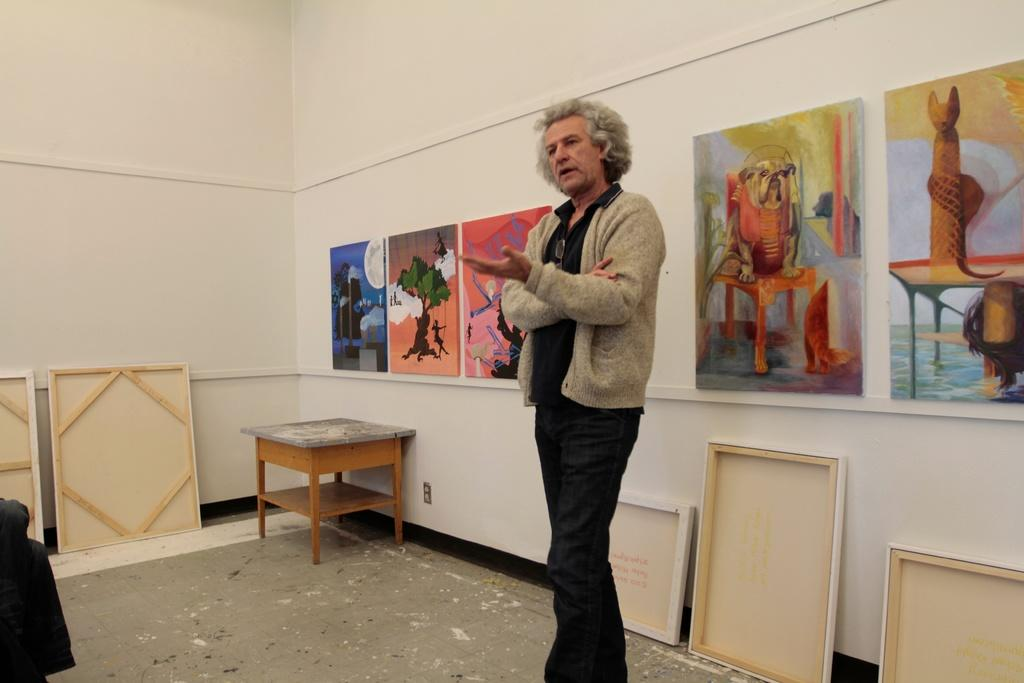What is the main subject of the picture? There is a person standing in the picture. Where is the person located? The person is in a room. What furniture can be seen in the room? There is a table in the room. What decorative elements are present in the background? There are photographs attached to the wall in the background. What type of chin can be seen on the road in the image? There is no chin or road present in the image; it features a person standing in a room with a table and photographs on the wall. 